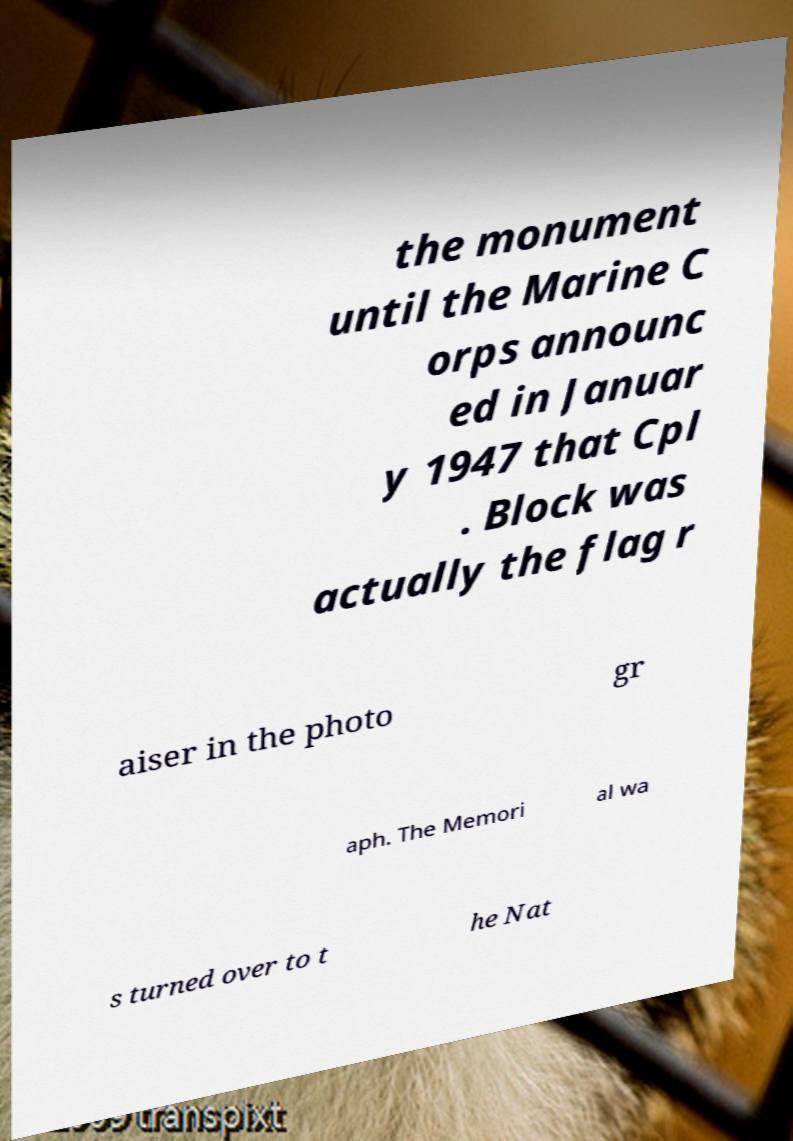Please read and relay the text visible in this image. What does it say? the monument until the Marine C orps announc ed in Januar y 1947 that Cpl . Block was actually the flag r aiser in the photo gr aph. The Memori al wa s turned over to t he Nat 